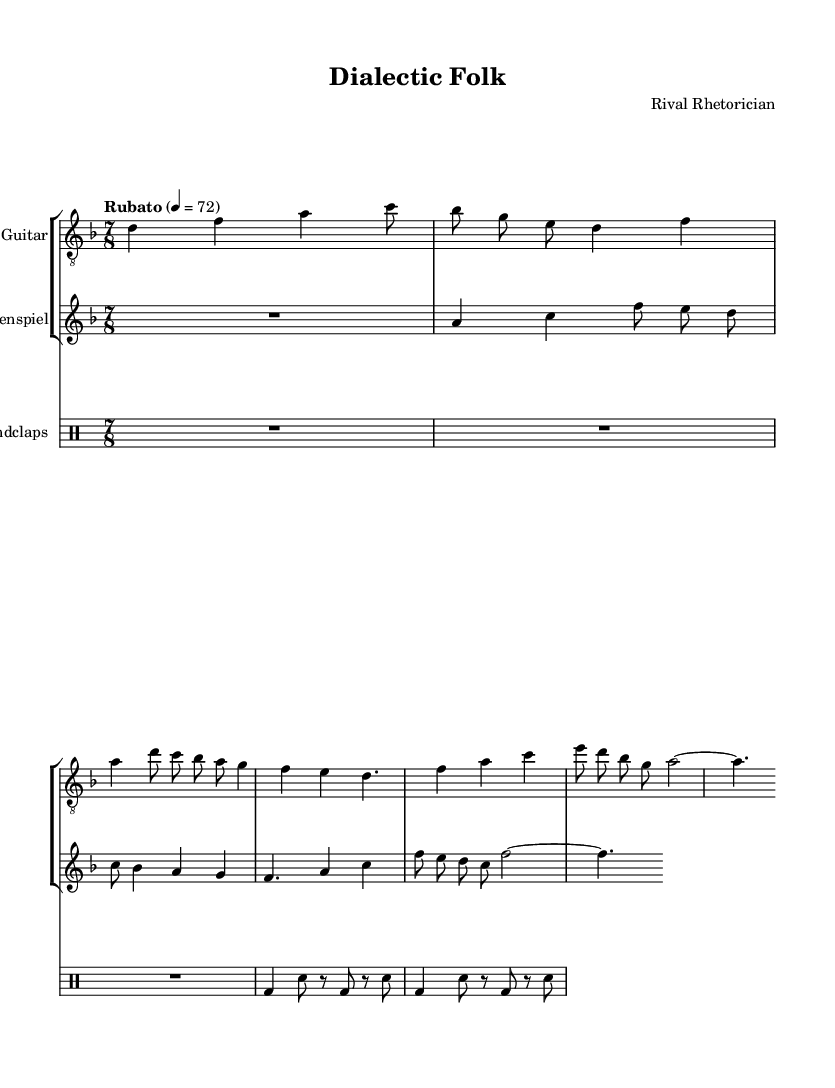What is the key signature of this music? The key signature is indicated at the beginning of the score. In this case, it shows two flats, which corresponds to B flat major or G minor, but since the music is in D minor, it aligns with the relative minor, which is revealed through the notes being played.
Answer: D minor What is the time signature of this music? The time signature is located at the beginning of the piece, right after the key signature. It is written as 7/8, indicating that each measure contains seven eighth-note beats. This irregular time signature contributes to the experimental nature of the piece.
Answer: 7/8 What is the tempo marking in this music? The tempo marking can be found at the start of the score, indicating the speed at which the piece should be played. It is described as "Rubato," which means that the tempo can fluctuate, allowing for expressive interpretations.
Answer: Rubato How many measures are in the chorus section? By counting the measures within the specified chorus section of the music (based on the rhythm and notes provided), we find that there are four measures indicated.
Answer: 4 Which rhetorical devices are present in the lyrics? To identify rhetorical devices, one examines the lyrics, specifically phrases like "Ad hominem," which refers to a common logical fallacy used in debate. The presence of these terms indicates an exploration of rhetoric rather than a straightforward narrative.
Answer: Ad hominem What instruments are used in this composition? The instruments are clearly specified in the score with their respective staves labeled. Specifically, there are parts for Guitar, Glockenspiel, and Handclaps, showcasing a blend of melodic and rhythmic elements.
Answer: Guitar, Glockenspiel, Handclaps What literary device is used in the phrase "straw man"? The phrase "straw man" is a direct reference to a type of fallacy in rhetorical debate where an opponent's argument is misrepresented. This reflects the thematic focus on examining and deconstructing arguments through music.
Answer: Metaphor 